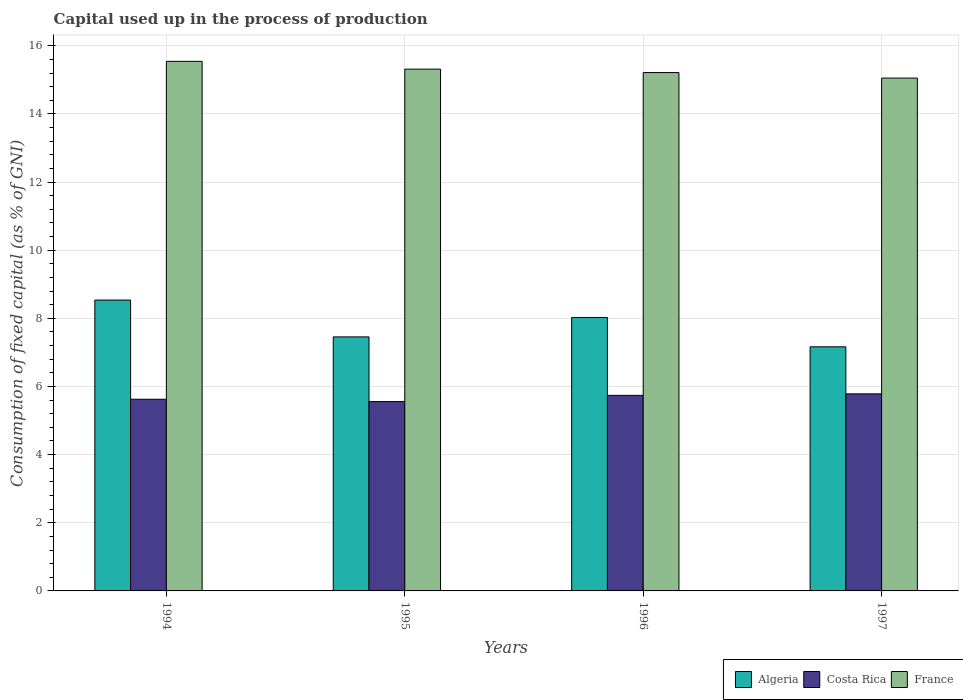How many different coloured bars are there?
Your answer should be compact. 3. How many groups of bars are there?
Your answer should be compact. 4. How many bars are there on the 2nd tick from the right?
Offer a very short reply. 3. What is the label of the 2nd group of bars from the left?
Give a very brief answer. 1995. In how many cases, is the number of bars for a given year not equal to the number of legend labels?
Your response must be concise. 0. What is the capital used up in the process of production in Costa Rica in 1997?
Make the answer very short. 5.78. Across all years, what is the maximum capital used up in the process of production in France?
Offer a very short reply. 15.54. Across all years, what is the minimum capital used up in the process of production in France?
Provide a succinct answer. 15.05. In which year was the capital used up in the process of production in Algeria minimum?
Keep it short and to the point. 1997. What is the total capital used up in the process of production in Costa Rica in the graph?
Provide a succinct answer. 22.71. What is the difference between the capital used up in the process of production in Algeria in 1994 and that in 1996?
Give a very brief answer. 0.51. What is the difference between the capital used up in the process of production in France in 1997 and the capital used up in the process of production in Algeria in 1996?
Ensure brevity in your answer.  7.03. What is the average capital used up in the process of production in Algeria per year?
Give a very brief answer. 7.8. In the year 1994, what is the difference between the capital used up in the process of production in Algeria and capital used up in the process of production in France?
Your answer should be compact. -7.01. What is the ratio of the capital used up in the process of production in France in 1995 to that in 1997?
Offer a very short reply. 1.02. Is the capital used up in the process of production in Costa Rica in 1994 less than that in 1995?
Offer a terse response. No. What is the difference between the highest and the second highest capital used up in the process of production in France?
Your response must be concise. 0.23. What is the difference between the highest and the lowest capital used up in the process of production in France?
Your answer should be compact. 0.49. In how many years, is the capital used up in the process of production in Costa Rica greater than the average capital used up in the process of production in Costa Rica taken over all years?
Your answer should be compact. 2. What does the 3rd bar from the right in 1994 represents?
Give a very brief answer. Algeria. How many bars are there?
Offer a very short reply. 12. Are all the bars in the graph horizontal?
Your response must be concise. No. Are the values on the major ticks of Y-axis written in scientific E-notation?
Keep it short and to the point. No. Where does the legend appear in the graph?
Ensure brevity in your answer.  Bottom right. How many legend labels are there?
Make the answer very short. 3. How are the legend labels stacked?
Ensure brevity in your answer.  Horizontal. What is the title of the graph?
Offer a terse response. Capital used up in the process of production. Does "Guyana" appear as one of the legend labels in the graph?
Your response must be concise. No. What is the label or title of the X-axis?
Your response must be concise. Years. What is the label or title of the Y-axis?
Keep it short and to the point. Consumption of fixed capital (as % of GNI). What is the Consumption of fixed capital (as % of GNI) in Algeria in 1994?
Give a very brief answer. 8.54. What is the Consumption of fixed capital (as % of GNI) of Costa Rica in 1994?
Offer a terse response. 5.63. What is the Consumption of fixed capital (as % of GNI) in France in 1994?
Your answer should be compact. 15.54. What is the Consumption of fixed capital (as % of GNI) of Algeria in 1995?
Offer a very short reply. 7.46. What is the Consumption of fixed capital (as % of GNI) of Costa Rica in 1995?
Your response must be concise. 5.56. What is the Consumption of fixed capital (as % of GNI) of France in 1995?
Offer a very short reply. 15.31. What is the Consumption of fixed capital (as % of GNI) of Algeria in 1996?
Provide a short and direct response. 8.03. What is the Consumption of fixed capital (as % of GNI) of Costa Rica in 1996?
Your answer should be compact. 5.74. What is the Consumption of fixed capital (as % of GNI) in France in 1996?
Offer a very short reply. 15.21. What is the Consumption of fixed capital (as % of GNI) in Algeria in 1997?
Provide a short and direct response. 7.16. What is the Consumption of fixed capital (as % of GNI) in Costa Rica in 1997?
Provide a short and direct response. 5.78. What is the Consumption of fixed capital (as % of GNI) in France in 1997?
Provide a succinct answer. 15.05. Across all years, what is the maximum Consumption of fixed capital (as % of GNI) in Algeria?
Offer a very short reply. 8.54. Across all years, what is the maximum Consumption of fixed capital (as % of GNI) in Costa Rica?
Your answer should be very brief. 5.78. Across all years, what is the maximum Consumption of fixed capital (as % of GNI) of France?
Give a very brief answer. 15.54. Across all years, what is the minimum Consumption of fixed capital (as % of GNI) in Algeria?
Give a very brief answer. 7.16. Across all years, what is the minimum Consumption of fixed capital (as % of GNI) of Costa Rica?
Make the answer very short. 5.56. Across all years, what is the minimum Consumption of fixed capital (as % of GNI) in France?
Keep it short and to the point. 15.05. What is the total Consumption of fixed capital (as % of GNI) in Algeria in the graph?
Provide a short and direct response. 31.18. What is the total Consumption of fixed capital (as % of GNI) of Costa Rica in the graph?
Make the answer very short. 22.71. What is the total Consumption of fixed capital (as % of GNI) in France in the graph?
Provide a short and direct response. 61.12. What is the difference between the Consumption of fixed capital (as % of GNI) of Algeria in 1994 and that in 1995?
Your answer should be compact. 1.08. What is the difference between the Consumption of fixed capital (as % of GNI) of Costa Rica in 1994 and that in 1995?
Provide a succinct answer. 0.07. What is the difference between the Consumption of fixed capital (as % of GNI) of France in 1994 and that in 1995?
Keep it short and to the point. 0.23. What is the difference between the Consumption of fixed capital (as % of GNI) in Algeria in 1994 and that in 1996?
Make the answer very short. 0.51. What is the difference between the Consumption of fixed capital (as % of GNI) of Costa Rica in 1994 and that in 1996?
Give a very brief answer. -0.11. What is the difference between the Consumption of fixed capital (as % of GNI) in France in 1994 and that in 1996?
Keep it short and to the point. 0.33. What is the difference between the Consumption of fixed capital (as % of GNI) of Algeria in 1994 and that in 1997?
Give a very brief answer. 1.37. What is the difference between the Consumption of fixed capital (as % of GNI) of Costa Rica in 1994 and that in 1997?
Offer a terse response. -0.16. What is the difference between the Consumption of fixed capital (as % of GNI) in France in 1994 and that in 1997?
Provide a short and direct response. 0.49. What is the difference between the Consumption of fixed capital (as % of GNI) in Algeria in 1995 and that in 1996?
Make the answer very short. -0.57. What is the difference between the Consumption of fixed capital (as % of GNI) of Costa Rica in 1995 and that in 1996?
Your answer should be compact. -0.18. What is the difference between the Consumption of fixed capital (as % of GNI) of France in 1995 and that in 1996?
Provide a short and direct response. 0.1. What is the difference between the Consumption of fixed capital (as % of GNI) in Algeria in 1995 and that in 1997?
Offer a very short reply. 0.29. What is the difference between the Consumption of fixed capital (as % of GNI) of Costa Rica in 1995 and that in 1997?
Keep it short and to the point. -0.23. What is the difference between the Consumption of fixed capital (as % of GNI) of France in 1995 and that in 1997?
Your answer should be compact. 0.26. What is the difference between the Consumption of fixed capital (as % of GNI) in Algeria in 1996 and that in 1997?
Your answer should be compact. 0.86. What is the difference between the Consumption of fixed capital (as % of GNI) of Costa Rica in 1996 and that in 1997?
Keep it short and to the point. -0.04. What is the difference between the Consumption of fixed capital (as % of GNI) of France in 1996 and that in 1997?
Keep it short and to the point. 0.16. What is the difference between the Consumption of fixed capital (as % of GNI) in Algeria in 1994 and the Consumption of fixed capital (as % of GNI) in Costa Rica in 1995?
Your answer should be compact. 2.98. What is the difference between the Consumption of fixed capital (as % of GNI) of Algeria in 1994 and the Consumption of fixed capital (as % of GNI) of France in 1995?
Your answer should be very brief. -6.78. What is the difference between the Consumption of fixed capital (as % of GNI) of Costa Rica in 1994 and the Consumption of fixed capital (as % of GNI) of France in 1995?
Ensure brevity in your answer.  -9.69. What is the difference between the Consumption of fixed capital (as % of GNI) of Algeria in 1994 and the Consumption of fixed capital (as % of GNI) of Costa Rica in 1996?
Keep it short and to the point. 2.8. What is the difference between the Consumption of fixed capital (as % of GNI) in Algeria in 1994 and the Consumption of fixed capital (as % of GNI) in France in 1996?
Your response must be concise. -6.68. What is the difference between the Consumption of fixed capital (as % of GNI) of Costa Rica in 1994 and the Consumption of fixed capital (as % of GNI) of France in 1996?
Provide a short and direct response. -9.59. What is the difference between the Consumption of fixed capital (as % of GNI) in Algeria in 1994 and the Consumption of fixed capital (as % of GNI) in Costa Rica in 1997?
Ensure brevity in your answer.  2.75. What is the difference between the Consumption of fixed capital (as % of GNI) in Algeria in 1994 and the Consumption of fixed capital (as % of GNI) in France in 1997?
Offer a terse response. -6.52. What is the difference between the Consumption of fixed capital (as % of GNI) of Costa Rica in 1994 and the Consumption of fixed capital (as % of GNI) of France in 1997?
Offer a terse response. -9.43. What is the difference between the Consumption of fixed capital (as % of GNI) in Algeria in 1995 and the Consumption of fixed capital (as % of GNI) in Costa Rica in 1996?
Your answer should be very brief. 1.72. What is the difference between the Consumption of fixed capital (as % of GNI) in Algeria in 1995 and the Consumption of fixed capital (as % of GNI) in France in 1996?
Ensure brevity in your answer.  -7.76. What is the difference between the Consumption of fixed capital (as % of GNI) in Costa Rica in 1995 and the Consumption of fixed capital (as % of GNI) in France in 1996?
Keep it short and to the point. -9.66. What is the difference between the Consumption of fixed capital (as % of GNI) of Algeria in 1995 and the Consumption of fixed capital (as % of GNI) of Costa Rica in 1997?
Give a very brief answer. 1.67. What is the difference between the Consumption of fixed capital (as % of GNI) in Algeria in 1995 and the Consumption of fixed capital (as % of GNI) in France in 1997?
Your answer should be very brief. -7.6. What is the difference between the Consumption of fixed capital (as % of GNI) of Costa Rica in 1995 and the Consumption of fixed capital (as % of GNI) of France in 1997?
Provide a succinct answer. -9.49. What is the difference between the Consumption of fixed capital (as % of GNI) of Algeria in 1996 and the Consumption of fixed capital (as % of GNI) of Costa Rica in 1997?
Your answer should be very brief. 2.24. What is the difference between the Consumption of fixed capital (as % of GNI) of Algeria in 1996 and the Consumption of fixed capital (as % of GNI) of France in 1997?
Your response must be concise. -7.03. What is the difference between the Consumption of fixed capital (as % of GNI) of Costa Rica in 1996 and the Consumption of fixed capital (as % of GNI) of France in 1997?
Give a very brief answer. -9.31. What is the average Consumption of fixed capital (as % of GNI) in Algeria per year?
Give a very brief answer. 7.8. What is the average Consumption of fixed capital (as % of GNI) of Costa Rica per year?
Your answer should be very brief. 5.68. What is the average Consumption of fixed capital (as % of GNI) of France per year?
Provide a short and direct response. 15.28. In the year 1994, what is the difference between the Consumption of fixed capital (as % of GNI) of Algeria and Consumption of fixed capital (as % of GNI) of Costa Rica?
Ensure brevity in your answer.  2.91. In the year 1994, what is the difference between the Consumption of fixed capital (as % of GNI) in Algeria and Consumption of fixed capital (as % of GNI) in France?
Your answer should be very brief. -7.01. In the year 1994, what is the difference between the Consumption of fixed capital (as % of GNI) in Costa Rica and Consumption of fixed capital (as % of GNI) in France?
Offer a very short reply. -9.92. In the year 1995, what is the difference between the Consumption of fixed capital (as % of GNI) of Algeria and Consumption of fixed capital (as % of GNI) of Costa Rica?
Your answer should be very brief. 1.9. In the year 1995, what is the difference between the Consumption of fixed capital (as % of GNI) of Algeria and Consumption of fixed capital (as % of GNI) of France?
Ensure brevity in your answer.  -7.86. In the year 1995, what is the difference between the Consumption of fixed capital (as % of GNI) of Costa Rica and Consumption of fixed capital (as % of GNI) of France?
Your answer should be compact. -9.76. In the year 1996, what is the difference between the Consumption of fixed capital (as % of GNI) in Algeria and Consumption of fixed capital (as % of GNI) in Costa Rica?
Keep it short and to the point. 2.29. In the year 1996, what is the difference between the Consumption of fixed capital (as % of GNI) of Algeria and Consumption of fixed capital (as % of GNI) of France?
Your answer should be very brief. -7.19. In the year 1996, what is the difference between the Consumption of fixed capital (as % of GNI) in Costa Rica and Consumption of fixed capital (as % of GNI) in France?
Make the answer very short. -9.47. In the year 1997, what is the difference between the Consumption of fixed capital (as % of GNI) of Algeria and Consumption of fixed capital (as % of GNI) of Costa Rica?
Make the answer very short. 1.38. In the year 1997, what is the difference between the Consumption of fixed capital (as % of GNI) of Algeria and Consumption of fixed capital (as % of GNI) of France?
Your response must be concise. -7.89. In the year 1997, what is the difference between the Consumption of fixed capital (as % of GNI) of Costa Rica and Consumption of fixed capital (as % of GNI) of France?
Your response must be concise. -9.27. What is the ratio of the Consumption of fixed capital (as % of GNI) of Algeria in 1994 to that in 1995?
Offer a very short reply. 1.14. What is the ratio of the Consumption of fixed capital (as % of GNI) in Costa Rica in 1994 to that in 1995?
Keep it short and to the point. 1.01. What is the ratio of the Consumption of fixed capital (as % of GNI) in France in 1994 to that in 1995?
Offer a terse response. 1.01. What is the ratio of the Consumption of fixed capital (as % of GNI) of Algeria in 1994 to that in 1996?
Provide a short and direct response. 1.06. What is the ratio of the Consumption of fixed capital (as % of GNI) in Costa Rica in 1994 to that in 1996?
Make the answer very short. 0.98. What is the ratio of the Consumption of fixed capital (as % of GNI) of France in 1994 to that in 1996?
Provide a short and direct response. 1.02. What is the ratio of the Consumption of fixed capital (as % of GNI) of Algeria in 1994 to that in 1997?
Keep it short and to the point. 1.19. What is the ratio of the Consumption of fixed capital (as % of GNI) of Costa Rica in 1994 to that in 1997?
Ensure brevity in your answer.  0.97. What is the ratio of the Consumption of fixed capital (as % of GNI) in France in 1994 to that in 1997?
Your answer should be compact. 1.03. What is the ratio of the Consumption of fixed capital (as % of GNI) of Algeria in 1995 to that in 1996?
Provide a succinct answer. 0.93. What is the ratio of the Consumption of fixed capital (as % of GNI) in Costa Rica in 1995 to that in 1996?
Give a very brief answer. 0.97. What is the ratio of the Consumption of fixed capital (as % of GNI) in France in 1995 to that in 1996?
Your answer should be compact. 1.01. What is the ratio of the Consumption of fixed capital (as % of GNI) of Algeria in 1995 to that in 1997?
Offer a terse response. 1.04. What is the ratio of the Consumption of fixed capital (as % of GNI) in Costa Rica in 1995 to that in 1997?
Your answer should be very brief. 0.96. What is the ratio of the Consumption of fixed capital (as % of GNI) of France in 1995 to that in 1997?
Your answer should be very brief. 1.02. What is the ratio of the Consumption of fixed capital (as % of GNI) of Algeria in 1996 to that in 1997?
Your response must be concise. 1.12. What is the ratio of the Consumption of fixed capital (as % of GNI) in France in 1996 to that in 1997?
Your response must be concise. 1.01. What is the difference between the highest and the second highest Consumption of fixed capital (as % of GNI) of Algeria?
Provide a succinct answer. 0.51. What is the difference between the highest and the second highest Consumption of fixed capital (as % of GNI) of Costa Rica?
Provide a succinct answer. 0.04. What is the difference between the highest and the second highest Consumption of fixed capital (as % of GNI) in France?
Provide a succinct answer. 0.23. What is the difference between the highest and the lowest Consumption of fixed capital (as % of GNI) in Algeria?
Ensure brevity in your answer.  1.37. What is the difference between the highest and the lowest Consumption of fixed capital (as % of GNI) in Costa Rica?
Your response must be concise. 0.23. What is the difference between the highest and the lowest Consumption of fixed capital (as % of GNI) of France?
Ensure brevity in your answer.  0.49. 